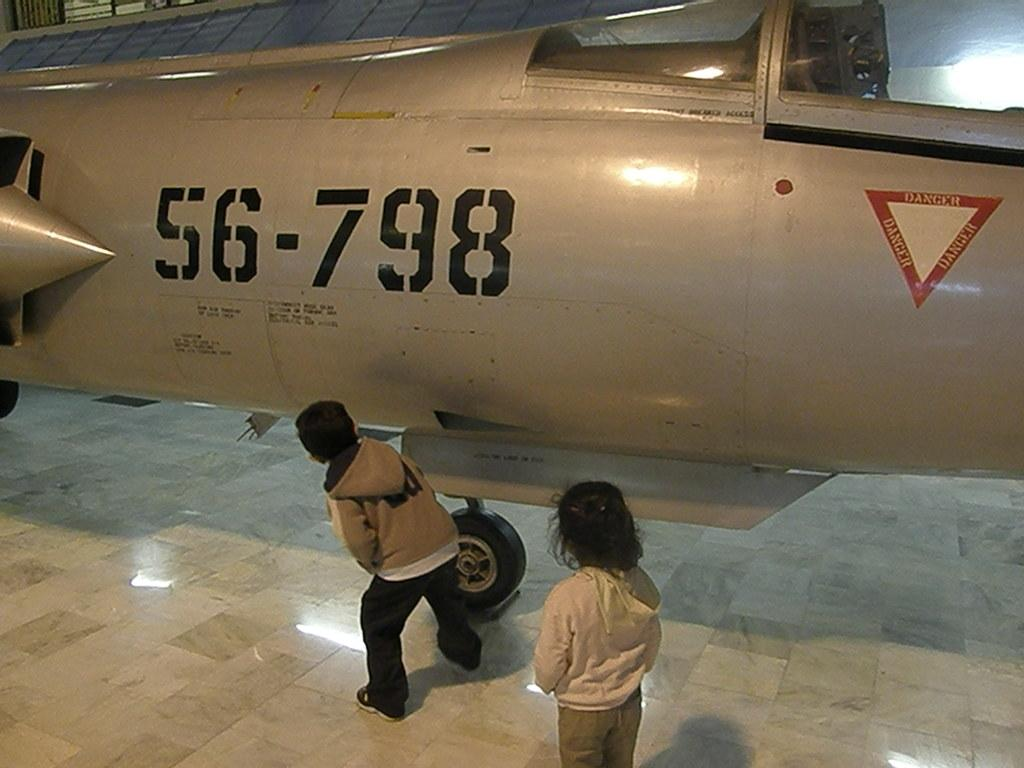<image>
Summarize the visual content of the image. Children by a gray airplane that has a number 8 on it. 